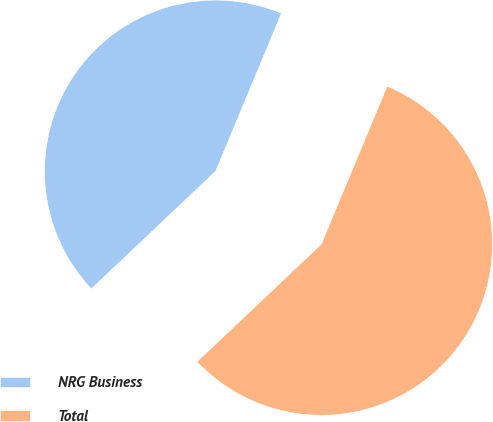Convert chart. <chart><loc_0><loc_0><loc_500><loc_500><pie_chart><fcel>NRG Business<fcel>Total<nl><fcel>43.34%<fcel>56.66%<nl></chart> 